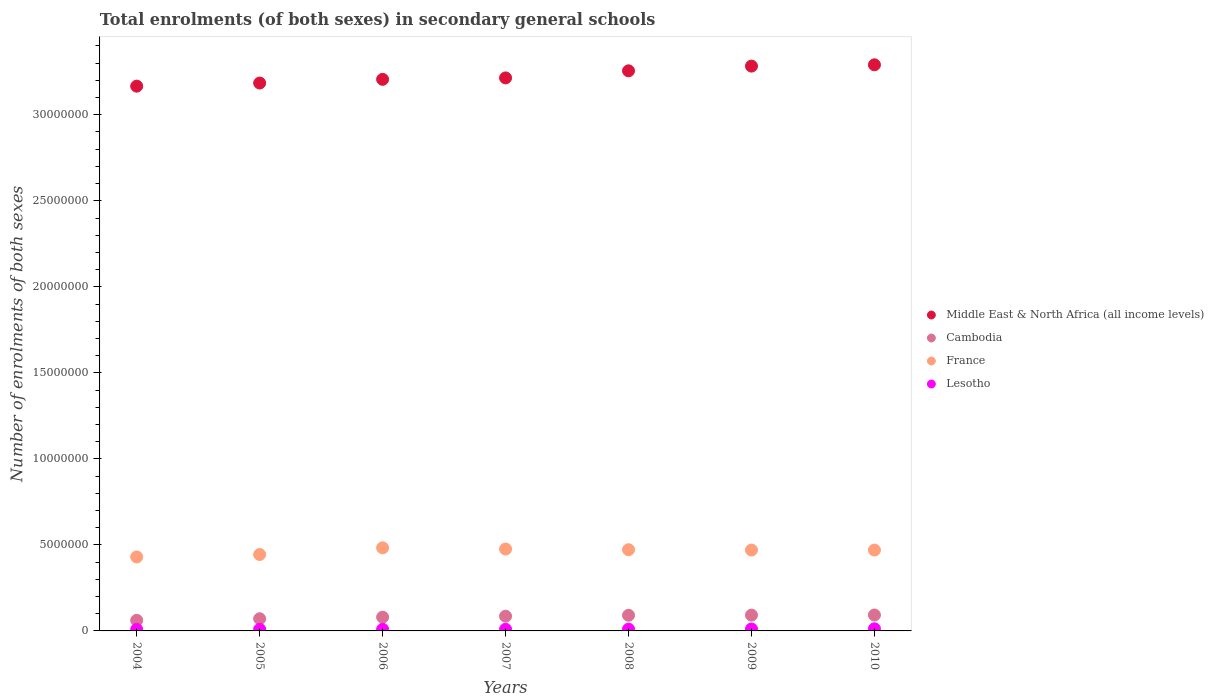How many different coloured dotlines are there?
Ensure brevity in your answer.  4. What is the number of enrolments in secondary schools in France in 2004?
Offer a very short reply. 4.30e+06. Across all years, what is the maximum number of enrolments in secondary schools in France?
Offer a terse response. 4.83e+06. Across all years, what is the minimum number of enrolments in secondary schools in Cambodia?
Your answer should be very brief. 6.16e+05. What is the total number of enrolments in secondary schools in Middle East & North Africa (all income levels) in the graph?
Keep it short and to the point. 2.26e+08. What is the difference between the number of enrolments in secondary schools in France in 2004 and that in 2010?
Give a very brief answer. -4.02e+05. What is the difference between the number of enrolments in secondary schools in Cambodia in 2006 and the number of enrolments in secondary schools in France in 2004?
Offer a terse response. -3.50e+06. What is the average number of enrolments in secondary schools in Cambodia per year?
Offer a very short reply. 8.19e+05. In the year 2004, what is the difference between the number of enrolments in secondary schools in France and number of enrolments in secondary schools in Middle East & North Africa (all income levels)?
Your answer should be very brief. -2.74e+07. What is the ratio of the number of enrolments in secondary schools in Lesotho in 2007 to that in 2008?
Ensure brevity in your answer.  0.95. Is the number of enrolments in secondary schools in Middle East & North Africa (all income levels) in 2005 less than that in 2010?
Your response must be concise. Yes. What is the difference between the highest and the second highest number of enrolments in secondary schools in Cambodia?
Make the answer very short. 7080. What is the difference between the highest and the lowest number of enrolments in secondary schools in Middle East & North Africa (all income levels)?
Your response must be concise. 1.24e+06. Is it the case that in every year, the sum of the number of enrolments in secondary schools in Cambodia and number of enrolments in secondary schools in France  is greater than the sum of number of enrolments in secondary schools in Lesotho and number of enrolments in secondary schools in Middle East & North Africa (all income levels)?
Your answer should be compact. No. Is it the case that in every year, the sum of the number of enrolments in secondary schools in Cambodia and number of enrolments in secondary schools in Middle East & North Africa (all income levels)  is greater than the number of enrolments in secondary schools in France?
Offer a very short reply. Yes. Does the number of enrolments in secondary schools in Cambodia monotonically increase over the years?
Offer a very short reply. Yes. Is the number of enrolments in secondary schools in Cambodia strictly greater than the number of enrolments in secondary schools in Middle East & North Africa (all income levels) over the years?
Provide a succinct answer. No. How many dotlines are there?
Your answer should be compact. 4. What is the difference between two consecutive major ticks on the Y-axis?
Offer a terse response. 5.00e+06. Does the graph contain any zero values?
Offer a terse response. No. How are the legend labels stacked?
Provide a short and direct response. Vertical. What is the title of the graph?
Offer a terse response. Total enrolments (of both sexes) in secondary general schools. What is the label or title of the X-axis?
Your answer should be compact. Years. What is the label or title of the Y-axis?
Your answer should be very brief. Number of enrolments of both sexes. What is the Number of enrolments of both sexes of Middle East & North Africa (all income levels) in 2004?
Offer a very short reply. 3.17e+07. What is the Number of enrolments of both sexes of Cambodia in 2004?
Your response must be concise. 6.16e+05. What is the Number of enrolments of both sexes of France in 2004?
Your answer should be very brief. 4.30e+06. What is the Number of enrolments of both sexes in Lesotho in 2004?
Ensure brevity in your answer.  8.81e+04. What is the Number of enrolments of both sexes of Middle East & North Africa (all income levels) in 2005?
Ensure brevity in your answer.  3.18e+07. What is the Number of enrolments of both sexes of Cambodia in 2005?
Provide a succinct answer. 7.08e+05. What is the Number of enrolments of both sexes of France in 2005?
Ensure brevity in your answer.  4.44e+06. What is the Number of enrolments of both sexes of Lesotho in 2005?
Offer a very short reply. 9.31e+04. What is the Number of enrolments of both sexes of Middle East & North Africa (all income levels) in 2006?
Ensure brevity in your answer.  3.21e+07. What is the Number of enrolments of both sexes in Cambodia in 2006?
Your answer should be very brief. 7.99e+05. What is the Number of enrolments of both sexes in France in 2006?
Offer a very short reply. 4.83e+06. What is the Number of enrolments of both sexes of Lesotho in 2006?
Provide a succinct answer. 9.45e+04. What is the Number of enrolments of both sexes in Middle East & North Africa (all income levels) in 2007?
Keep it short and to the point. 3.21e+07. What is the Number of enrolments of both sexes in Cambodia in 2007?
Provide a short and direct response. 8.56e+05. What is the Number of enrolments of both sexes of France in 2007?
Ensure brevity in your answer.  4.76e+06. What is the Number of enrolments of both sexes of Lesotho in 2007?
Your answer should be very brief. 9.79e+04. What is the Number of enrolments of both sexes in Middle East & North Africa (all income levels) in 2008?
Provide a succinct answer. 3.26e+07. What is the Number of enrolments of both sexes in Cambodia in 2008?
Offer a very short reply. 9.09e+05. What is the Number of enrolments of both sexes in France in 2008?
Provide a short and direct response. 4.72e+06. What is the Number of enrolments of both sexes in Lesotho in 2008?
Provide a succinct answer. 1.03e+05. What is the Number of enrolments of both sexes of Middle East & North Africa (all income levels) in 2009?
Ensure brevity in your answer.  3.28e+07. What is the Number of enrolments of both sexes in Cambodia in 2009?
Ensure brevity in your answer.  9.19e+05. What is the Number of enrolments of both sexes of France in 2009?
Your response must be concise. 4.70e+06. What is the Number of enrolments of both sexes of Lesotho in 2009?
Keep it short and to the point. 1.11e+05. What is the Number of enrolments of both sexes in Middle East & North Africa (all income levels) in 2010?
Keep it short and to the point. 3.29e+07. What is the Number of enrolments of both sexes of Cambodia in 2010?
Give a very brief answer. 9.26e+05. What is the Number of enrolments of both sexes of France in 2010?
Offer a very short reply. 4.70e+06. What is the Number of enrolments of both sexes of Lesotho in 2010?
Your answer should be very brief. 1.23e+05. Across all years, what is the maximum Number of enrolments of both sexes in Middle East & North Africa (all income levels)?
Offer a very short reply. 3.29e+07. Across all years, what is the maximum Number of enrolments of both sexes in Cambodia?
Provide a succinct answer. 9.26e+05. Across all years, what is the maximum Number of enrolments of both sexes in France?
Your response must be concise. 4.83e+06. Across all years, what is the maximum Number of enrolments of both sexes in Lesotho?
Keep it short and to the point. 1.23e+05. Across all years, what is the minimum Number of enrolments of both sexes of Middle East & North Africa (all income levels)?
Your answer should be very brief. 3.17e+07. Across all years, what is the minimum Number of enrolments of both sexes in Cambodia?
Offer a very short reply. 6.16e+05. Across all years, what is the minimum Number of enrolments of both sexes in France?
Offer a very short reply. 4.30e+06. Across all years, what is the minimum Number of enrolments of both sexes in Lesotho?
Make the answer very short. 8.81e+04. What is the total Number of enrolments of both sexes in Middle East & North Africa (all income levels) in the graph?
Offer a very short reply. 2.26e+08. What is the total Number of enrolments of both sexes in Cambodia in the graph?
Keep it short and to the point. 5.73e+06. What is the total Number of enrolments of both sexes in France in the graph?
Make the answer very short. 3.25e+07. What is the total Number of enrolments of both sexes in Lesotho in the graph?
Provide a short and direct response. 7.12e+05. What is the difference between the Number of enrolments of both sexes of Middle East & North Africa (all income levels) in 2004 and that in 2005?
Provide a short and direct response. -1.81e+05. What is the difference between the Number of enrolments of both sexes in Cambodia in 2004 and that in 2005?
Offer a terse response. -9.24e+04. What is the difference between the Number of enrolments of both sexes of France in 2004 and that in 2005?
Make the answer very short. -1.43e+05. What is the difference between the Number of enrolments of both sexes in Lesotho in 2004 and that in 2005?
Offer a very short reply. -4954. What is the difference between the Number of enrolments of both sexes in Middle East & North Africa (all income levels) in 2004 and that in 2006?
Offer a terse response. -3.96e+05. What is the difference between the Number of enrolments of both sexes of Cambodia in 2004 and that in 2006?
Provide a short and direct response. -1.83e+05. What is the difference between the Number of enrolments of both sexes in France in 2004 and that in 2006?
Your response must be concise. -5.31e+05. What is the difference between the Number of enrolments of both sexes in Lesotho in 2004 and that in 2006?
Ensure brevity in your answer.  -6403. What is the difference between the Number of enrolments of both sexes of Middle East & North Africa (all income levels) in 2004 and that in 2007?
Your response must be concise. -4.79e+05. What is the difference between the Number of enrolments of both sexes of Cambodia in 2004 and that in 2007?
Make the answer very short. -2.40e+05. What is the difference between the Number of enrolments of both sexes in France in 2004 and that in 2007?
Your answer should be compact. -4.62e+05. What is the difference between the Number of enrolments of both sexes in Lesotho in 2004 and that in 2007?
Ensure brevity in your answer.  -9794. What is the difference between the Number of enrolments of both sexes of Middle East & North Africa (all income levels) in 2004 and that in 2008?
Your answer should be compact. -8.91e+05. What is the difference between the Number of enrolments of both sexes in Cambodia in 2004 and that in 2008?
Ensure brevity in your answer.  -2.93e+05. What is the difference between the Number of enrolments of both sexes of France in 2004 and that in 2008?
Provide a succinct answer. -4.22e+05. What is the difference between the Number of enrolments of both sexes of Lesotho in 2004 and that in 2008?
Provide a short and direct response. -1.52e+04. What is the difference between the Number of enrolments of both sexes in Middle East & North Africa (all income levels) in 2004 and that in 2009?
Your answer should be very brief. -1.17e+06. What is the difference between the Number of enrolments of both sexes of Cambodia in 2004 and that in 2009?
Provide a short and direct response. -3.03e+05. What is the difference between the Number of enrolments of both sexes in France in 2004 and that in 2009?
Your answer should be very brief. -4.02e+05. What is the difference between the Number of enrolments of both sexes of Lesotho in 2004 and that in 2009?
Ensure brevity in your answer.  -2.33e+04. What is the difference between the Number of enrolments of both sexes of Middle East & North Africa (all income levels) in 2004 and that in 2010?
Give a very brief answer. -1.24e+06. What is the difference between the Number of enrolments of both sexes in Cambodia in 2004 and that in 2010?
Ensure brevity in your answer.  -3.10e+05. What is the difference between the Number of enrolments of both sexes in France in 2004 and that in 2010?
Offer a terse response. -4.02e+05. What is the difference between the Number of enrolments of both sexes of Lesotho in 2004 and that in 2010?
Provide a short and direct response. -3.52e+04. What is the difference between the Number of enrolments of both sexes in Middle East & North Africa (all income levels) in 2005 and that in 2006?
Ensure brevity in your answer.  -2.15e+05. What is the difference between the Number of enrolments of both sexes in Cambodia in 2005 and that in 2006?
Your answer should be compact. -9.04e+04. What is the difference between the Number of enrolments of both sexes in France in 2005 and that in 2006?
Your answer should be compact. -3.88e+05. What is the difference between the Number of enrolments of both sexes of Lesotho in 2005 and that in 2006?
Provide a short and direct response. -1449. What is the difference between the Number of enrolments of both sexes of Middle East & North Africa (all income levels) in 2005 and that in 2007?
Offer a terse response. -2.98e+05. What is the difference between the Number of enrolments of both sexes in Cambodia in 2005 and that in 2007?
Give a very brief answer. -1.48e+05. What is the difference between the Number of enrolments of both sexes in France in 2005 and that in 2007?
Give a very brief answer. -3.19e+05. What is the difference between the Number of enrolments of both sexes in Lesotho in 2005 and that in 2007?
Make the answer very short. -4840. What is the difference between the Number of enrolments of both sexes of Middle East & North Africa (all income levels) in 2005 and that in 2008?
Provide a succinct answer. -7.10e+05. What is the difference between the Number of enrolments of both sexes of Cambodia in 2005 and that in 2008?
Give a very brief answer. -2.01e+05. What is the difference between the Number of enrolments of both sexes of France in 2005 and that in 2008?
Your answer should be compact. -2.79e+05. What is the difference between the Number of enrolments of both sexes of Lesotho in 2005 and that in 2008?
Your answer should be very brief. -1.02e+04. What is the difference between the Number of enrolments of both sexes of Middle East & North Africa (all income levels) in 2005 and that in 2009?
Your answer should be very brief. -9.84e+05. What is the difference between the Number of enrolments of both sexes of Cambodia in 2005 and that in 2009?
Provide a short and direct response. -2.10e+05. What is the difference between the Number of enrolments of both sexes in France in 2005 and that in 2009?
Make the answer very short. -2.59e+05. What is the difference between the Number of enrolments of both sexes of Lesotho in 2005 and that in 2009?
Keep it short and to the point. -1.84e+04. What is the difference between the Number of enrolments of both sexes in Middle East & North Africa (all income levels) in 2005 and that in 2010?
Your answer should be compact. -1.06e+06. What is the difference between the Number of enrolments of both sexes of Cambodia in 2005 and that in 2010?
Your response must be concise. -2.17e+05. What is the difference between the Number of enrolments of both sexes in France in 2005 and that in 2010?
Give a very brief answer. -2.59e+05. What is the difference between the Number of enrolments of both sexes in Lesotho in 2005 and that in 2010?
Your answer should be very brief. -3.02e+04. What is the difference between the Number of enrolments of both sexes in Middle East & North Africa (all income levels) in 2006 and that in 2007?
Your answer should be very brief. -8.30e+04. What is the difference between the Number of enrolments of both sexes in Cambodia in 2006 and that in 2007?
Ensure brevity in your answer.  -5.73e+04. What is the difference between the Number of enrolments of both sexes in France in 2006 and that in 2007?
Provide a succinct answer. 6.85e+04. What is the difference between the Number of enrolments of both sexes of Lesotho in 2006 and that in 2007?
Offer a very short reply. -3391. What is the difference between the Number of enrolments of both sexes of Middle East & North Africa (all income levels) in 2006 and that in 2008?
Ensure brevity in your answer.  -4.95e+05. What is the difference between the Number of enrolments of both sexes in Cambodia in 2006 and that in 2008?
Offer a very short reply. -1.10e+05. What is the difference between the Number of enrolments of both sexes in France in 2006 and that in 2008?
Give a very brief answer. 1.09e+05. What is the difference between the Number of enrolments of both sexes in Lesotho in 2006 and that in 2008?
Provide a succinct answer. -8772. What is the difference between the Number of enrolments of both sexes in Middle East & North Africa (all income levels) in 2006 and that in 2009?
Give a very brief answer. -7.69e+05. What is the difference between the Number of enrolments of both sexes of Cambodia in 2006 and that in 2009?
Your answer should be compact. -1.20e+05. What is the difference between the Number of enrolments of both sexes of France in 2006 and that in 2009?
Give a very brief answer. 1.29e+05. What is the difference between the Number of enrolments of both sexes in Lesotho in 2006 and that in 2009?
Offer a very short reply. -1.69e+04. What is the difference between the Number of enrolments of both sexes in Middle East & North Africa (all income levels) in 2006 and that in 2010?
Provide a short and direct response. -8.45e+05. What is the difference between the Number of enrolments of both sexes of Cambodia in 2006 and that in 2010?
Give a very brief answer. -1.27e+05. What is the difference between the Number of enrolments of both sexes of France in 2006 and that in 2010?
Your answer should be very brief. 1.29e+05. What is the difference between the Number of enrolments of both sexes of Lesotho in 2006 and that in 2010?
Your answer should be very brief. -2.88e+04. What is the difference between the Number of enrolments of both sexes of Middle East & North Africa (all income levels) in 2007 and that in 2008?
Provide a short and direct response. -4.12e+05. What is the difference between the Number of enrolments of both sexes of Cambodia in 2007 and that in 2008?
Provide a succinct answer. -5.28e+04. What is the difference between the Number of enrolments of both sexes in France in 2007 and that in 2008?
Your answer should be compact. 4.01e+04. What is the difference between the Number of enrolments of both sexes in Lesotho in 2007 and that in 2008?
Make the answer very short. -5381. What is the difference between the Number of enrolments of both sexes in Middle East & North Africa (all income levels) in 2007 and that in 2009?
Offer a very short reply. -6.86e+05. What is the difference between the Number of enrolments of both sexes of Cambodia in 2007 and that in 2009?
Give a very brief answer. -6.25e+04. What is the difference between the Number of enrolments of both sexes of France in 2007 and that in 2009?
Your answer should be very brief. 6.07e+04. What is the difference between the Number of enrolments of both sexes in Lesotho in 2007 and that in 2009?
Your response must be concise. -1.35e+04. What is the difference between the Number of enrolments of both sexes of Middle East & North Africa (all income levels) in 2007 and that in 2010?
Your answer should be compact. -7.62e+05. What is the difference between the Number of enrolments of both sexes in Cambodia in 2007 and that in 2010?
Your response must be concise. -6.96e+04. What is the difference between the Number of enrolments of both sexes of France in 2007 and that in 2010?
Your answer should be compact. 6.08e+04. What is the difference between the Number of enrolments of both sexes in Lesotho in 2007 and that in 2010?
Ensure brevity in your answer.  -2.54e+04. What is the difference between the Number of enrolments of both sexes in Middle East & North Africa (all income levels) in 2008 and that in 2009?
Your answer should be very brief. -2.74e+05. What is the difference between the Number of enrolments of both sexes in Cambodia in 2008 and that in 2009?
Ensure brevity in your answer.  -9675. What is the difference between the Number of enrolments of both sexes of France in 2008 and that in 2009?
Offer a very short reply. 2.06e+04. What is the difference between the Number of enrolments of both sexes of Lesotho in 2008 and that in 2009?
Your answer should be very brief. -8163. What is the difference between the Number of enrolments of both sexes in Middle East & North Africa (all income levels) in 2008 and that in 2010?
Offer a terse response. -3.50e+05. What is the difference between the Number of enrolments of both sexes of Cambodia in 2008 and that in 2010?
Offer a terse response. -1.68e+04. What is the difference between the Number of enrolments of both sexes in France in 2008 and that in 2010?
Your answer should be very brief. 2.07e+04. What is the difference between the Number of enrolments of both sexes of Lesotho in 2008 and that in 2010?
Offer a terse response. -2.00e+04. What is the difference between the Number of enrolments of both sexes in Middle East & North Africa (all income levels) in 2009 and that in 2010?
Provide a succinct answer. -7.55e+04. What is the difference between the Number of enrolments of both sexes in Cambodia in 2009 and that in 2010?
Your answer should be very brief. -7080. What is the difference between the Number of enrolments of both sexes in France in 2009 and that in 2010?
Offer a very short reply. 153. What is the difference between the Number of enrolments of both sexes in Lesotho in 2009 and that in 2010?
Your answer should be compact. -1.18e+04. What is the difference between the Number of enrolments of both sexes in Middle East & North Africa (all income levels) in 2004 and the Number of enrolments of both sexes in Cambodia in 2005?
Offer a terse response. 3.10e+07. What is the difference between the Number of enrolments of both sexes of Middle East & North Africa (all income levels) in 2004 and the Number of enrolments of both sexes of France in 2005?
Offer a terse response. 2.72e+07. What is the difference between the Number of enrolments of both sexes in Middle East & North Africa (all income levels) in 2004 and the Number of enrolments of both sexes in Lesotho in 2005?
Keep it short and to the point. 3.16e+07. What is the difference between the Number of enrolments of both sexes of Cambodia in 2004 and the Number of enrolments of both sexes of France in 2005?
Keep it short and to the point. -3.83e+06. What is the difference between the Number of enrolments of both sexes of Cambodia in 2004 and the Number of enrolments of both sexes of Lesotho in 2005?
Keep it short and to the point. 5.23e+05. What is the difference between the Number of enrolments of both sexes of France in 2004 and the Number of enrolments of both sexes of Lesotho in 2005?
Offer a terse response. 4.21e+06. What is the difference between the Number of enrolments of both sexes of Middle East & North Africa (all income levels) in 2004 and the Number of enrolments of both sexes of Cambodia in 2006?
Your answer should be compact. 3.09e+07. What is the difference between the Number of enrolments of both sexes in Middle East & North Africa (all income levels) in 2004 and the Number of enrolments of both sexes in France in 2006?
Your answer should be compact. 2.68e+07. What is the difference between the Number of enrolments of both sexes of Middle East & North Africa (all income levels) in 2004 and the Number of enrolments of both sexes of Lesotho in 2006?
Provide a short and direct response. 3.16e+07. What is the difference between the Number of enrolments of both sexes of Cambodia in 2004 and the Number of enrolments of both sexes of France in 2006?
Provide a short and direct response. -4.21e+06. What is the difference between the Number of enrolments of both sexes in Cambodia in 2004 and the Number of enrolments of both sexes in Lesotho in 2006?
Offer a terse response. 5.22e+05. What is the difference between the Number of enrolments of both sexes of France in 2004 and the Number of enrolments of both sexes of Lesotho in 2006?
Offer a terse response. 4.20e+06. What is the difference between the Number of enrolments of both sexes of Middle East & North Africa (all income levels) in 2004 and the Number of enrolments of both sexes of Cambodia in 2007?
Offer a terse response. 3.08e+07. What is the difference between the Number of enrolments of both sexes of Middle East & North Africa (all income levels) in 2004 and the Number of enrolments of both sexes of France in 2007?
Give a very brief answer. 2.69e+07. What is the difference between the Number of enrolments of both sexes in Middle East & North Africa (all income levels) in 2004 and the Number of enrolments of both sexes in Lesotho in 2007?
Your answer should be very brief. 3.16e+07. What is the difference between the Number of enrolments of both sexes in Cambodia in 2004 and the Number of enrolments of both sexes in France in 2007?
Offer a terse response. -4.14e+06. What is the difference between the Number of enrolments of both sexes in Cambodia in 2004 and the Number of enrolments of both sexes in Lesotho in 2007?
Your answer should be very brief. 5.18e+05. What is the difference between the Number of enrolments of both sexes of France in 2004 and the Number of enrolments of both sexes of Lesotho in 2007?
Your answer should be compact. 4.20e+06. What is the difference between the Number of enrolments of both sexes in Middle East & North Africa (all income levels) in 2004 and the Number of enrolments of both sexes in Cambodia in 2008?
Your answer should be compact. 3.08e+07. What is the difference between the Number of enrolments of both sexes in Middle East & North Africa (all income levels) in 2004 and the Number of enrolments of both sexes in France in 2008?
Offer a terse response. 2.69e+07. What is the difference between the Number of enrolments of both sexes in Middle East & North Africa (all income levels) in 2004 and the Number of enrolments of both sexes in Lesotho in 2008?
Ensure brevity in your answer.  3.16e+07. What is the difference between the Number of enrolments of both sexes of Cambodia in 2004 and the Number of enrolments of both sexes of France in 2008?
Keep it short and to the point. -4.10e+06. What is the difference between the Number of enrolments of both sexes of Cambodia in 2004 and the Number of enrolments of both sexes of Lesotho in 2008?
Keep it short and to the point. 5.13e+05. What is the difference between the Number of enrolments of both sexes in France in 2004 and the Number of enrolments of both sexes in Lesotho in 2008?
Give a very brief answer. 4.20e+06. What is the difference between the Number of enrolments of both sexes of Middle East & North Africa (all income levels) in 2004 and the Number of enrolments of both sexes of Cambodia in 2009?
Provide a succinct answer. 3.07e+07. What is the difference between the Number of enrolments of both sexes of Middle East & North Africa (all income levels) in 2004 and the Number of enrolments of both sexes of France in 2009?
Your answer should be compact. 2.70e+07. What is the difference between the Number of enrolments of both sexes in Middle East & North Africa (all income levels) in 2004 and the Number of enrolments of both sexes in Lesotho in 2009?
Make the answer very short. 3.16e+07. What is the difference between the Number of enrolments of both sexes of Cambodia in 2004 and the Number of enrolments of both sexes of France in 2009?
Provide a short and direct response. -4.08e+06. What is the difference between the Number of enrolments of both sexes in Cambodia in 2004 and the Number of enrolments of both sexes in Lesotho in 2009?
Keep it short and to the point. 5.05e+05. What is the difference between the Number of enrolments of both sexes of France in 2004 and the Number of enrolments of both sexes of Lesotho in 2009?
Provide a short and direct response. 4.19e+06. What is the difference between the Number of enrolments of both sexes in Middle East & North Africa (all income levels) in 2004 and the Number of enrolments of both sexes in Cambodia in 2010?
Offer a terse response. 3.07e+07. What is the difference between the Number of enrolments of both sexes of Middle East & North Africa (all income levels) in 2004 and the Number of enrolments of both sexes of France in 2010?
Offer a very short reply. 2.70e+07. What is the difference between the Number of enrolments of both sexes in Middle East & North Africa (all income levels) in 2004 and the Number of enrolments of both sexes in Lesotho in 2010?
Keep it short and to the point. 3.15e+07. What is the difference between the Number of enrolments of both sexes of Cambodia in 2004 and the Number of enrolments of both sexes of France in 2010?
Keep it short and to the point. -4.08e+06. What is the difference between the Number of enrolments of both sexes in Cambodia in 2004 and the Number of enrolments of both sexes in Lesotho in 2010?
Offer a very short reply. 4.93e+05. What is the difference between the Number of enrolments of both sexes of France in 2004 and the Number of enrolments of both sexes of Lesotho in 2010?
Provide a short and direct response. 4.18e+06. What is the difference between the Number of enrolments of both sexes of Middle East & North Africa (all income levels) in 2005 and the Number of enrolments of both sexes of Cambodia in 2006?
Provide a short and direct response. 3.10e+07. What is the difference between the Number of enrolments of both sexes in Middle East & North Africa (all income levels) in 2005 and the Number of enrolments of both sexes in France in 2006?
Keep it short and to the point. 2.70e+07. What is the difference between the Number of enrolments of both sexes in Middle East & North Africa (all income levels) in 2005 and the Number of enrolments of both sexes in Lesotho in 2006?
Make the answer very short. 3.18e+07. What is the difference between the Number of enrolments of both sexes in Cambodia in 2005 and the Number of enrolments of both sexes in France in 2006?
Ensure brevity in your answer.  -4.12e+06. What is the difference between the Number of enrolments of both sexes of Cambodia in 2005 and the Number of enrolments of both sexes of Lesotho in 2006?
Your response must be concise. 6.14e+05. What is the difference between the Number of enrolments of both sexes of France in 2005 and the Number of enrolments of both sexes of Lesotho in 2006?
Offer a very short reply. 4.35e+06. What is the difference between the Number of enrolments of both sexes in Middle East & North Africa (all income levels) in 2005 and the Number of enrolments of both sexes in Cambodia in 2007?
Keep it short and to the point. 3.10e+07. What is the difference between the Number of enrolments of both sexes in Middle East & North Africa (all income levels) in 2005 and the Number of enrolments of both sexes in France in 2007?
Offer a very short reply. 2.71e+07. What is the difference between the Number of enrolments of both sexes of Middle East & North Africa (all income levels) in 2005 and the Number of enrolments of both sexes of Lesotho in 2007?
Your answer should be compact. 3.17e+07. What is the difference between the Number of enrolments of both sexes of Cambodia in 2005 and the Number of enrolments of both sexes of France in 2007?
Ensure brevity in your answer.  -4.05e+06. What is the difference between the Number of enrolments of both sexes of Cambodia in 2005 and the Number of enrolments of both sexes of Lesotho in 2007?
Offer a terse response. 6.11e+05. What is the difference between the Number of enrolments of both sexes in France in 2005 and the Number of enrolments of both sexes in Lesotho in 2007?
Provide a succinct answer. 4.34e+06. What is the difference between the Number of enrolments of both sexes in Middle East & North Africa (all income levels) in 2005 and the Number of enrolments of both sexes in Cambodia in 2008?
Make the answer very short. 3.09e+07. What is the difference between the Number of enrolments of both sexes in Middle East & North Africa (all income levels) in 2005 and the Number of enrolments of both sexes in France in 2008?
Your answer should be very brief. 2.71e+07. What is the difference between the Number of enrolments of both sexes of Middle East & North Africa (all income levels) in 2005 and the Number of enrolments of both sexes of Lesotho in 2008?
Your response must be concise. 3.17e+07. What is the difference between the Number of enrolments of both sexes of Cambodia in 2005 and the Number of enrolments of both sexes of France in 2008?
Offer a terse response. -4.01e+06. What is the difference between the Number of enrolments of both sexes in Cambodia in 2005 and the Number of enrolments of both sexes in Lesotho in 2008?
Offer a terse response. 6.05e+05. What is the difference between the Number of enrolments of both sexes of France in 2005 and the Number of enrolments of both sexes of Lesotho in 2008?
Provide a succinct answer. 4.34e+06. What is the difference between the Number of enrolments of both sexes in Middle East & North Africa (all income levels) in 2005 and the Number of enrolments of both sexes in Cambodia in 2009?
Make the answer very short. 3.09e+07. What is the difference between the Number of enrolments of both sexes of Middle East & North Africa (all income levels) in 2005 and the Number of enrolments of both sexes of France in 2009?
Your answer should be compact. 2.71e+07. What is the difference between the Number of enrolments of both sexes of Middle East & North Africa (all income levels) in 2005 and the Number of enrolments of both sexes of Lesotho in 2009?
Ensure brevity in your answer.  3.17e+07. What is the difference between the Number of enrolments of both sexes in Cambodia in 2005 and the Number of enrolments of both sexes in France in 2009?
Make the answer very short. -3.99e+06. What is the difference between the Number of enrolments of both sexes of Cambodia in 2005 and the Number of enrolments of both sexes of Lesotho in 2009?
Offer a very short reply. 5.97e+05. What is the difference between the Number of enrolments of both sexes in France in 2005 and the Number of enrolments of both sexes in Lesotho in 2009?
Provide a short and direct response. 4.33e+06. What is the difference between the Number of enrolments of both sexes in Middle East & North Africa (all income levels) in 2005 and the Number of enrolments of both sexes in Cambodia in 2010?
Your answer should be very brief. 3.09e+07. What is the difference between the Number of enrolments of both sexes in Middle East & North Africa (all income levels) in 2005 and the Number of enrolments of both sexes in France in 2010?
Give a very brief answer. 2.71e+07. What is the difference between the Number of enrolments of both sexes of Middle East & North Africa (all income levels) in 2005 and the Number of enrolments of both sexes of Lesotho in 2010?
Your response must be concise. 3.17e+07. What is the difference between the Number of enrolments of both sexes in Cambodia in 2005 and the Number of enrolments of both sexes in France in 2010?
Provide a short and direct response. -3.99e+06. What is the difference between the Number of enrolments of both sexes of Cambodia in 2005 and the Number of enrolments of both sexes of Lesotho in 2010?
Make the answer very short. 5.85e+05. What is the difference between the Number of enrolments of both sexes of France in 2005 and the Number of enrolments of both sexes of Lesotho in 2010?
Your answer should be very brief. 4.32e+06. What is the difference between the Number of enrolments of both sexes in Middle East & North Africa (all income levels) in 2006 and the Number of enrolments of both sexes in Cambodia in 2007?
Your response must be concise. 3.12e+07. What is the difference between the Number of enrolments of both sexes in Middle East & North Africa (all income levels) in 2006 and the Number of enrolments of both sexes in France in 2007?
Give a very brief answer. 2.73e+07. What is the difference between the Number of enrolments of both sexes of Middle East & North Africa (all income levels) in 2006 and the Number of enrolments of both sexes of Lesotho in 2007?
Keep it short and to the point. 3.20e+07. What is the difference between the Number of enrolments of both sexes of Cambodia in 2006 and the Number of enrolments of both sexes of France in 2007?
Offer a terse response. -3.96e+06. What is the difference between the Number of enrolments of both sexes in Cambodia in 2006 and the Number of enrolments of both sexes in Lesotho in 2007?
Offer a terse response. 7.01e+05. What is the difference between the Number of enrolments of both sexes of France in 2006 and the Number of enrolments of both sexes of Lesotho in 2007?
Your answer should be very brief. 4.73e+06. What is the difference between the Number of enrolments of both sexes of Middle East & North Africa (all income levels) in 2006 and the Number of enrolments of both sexes of Cambodia in 2008?
Make the answer very short. 3.12e+07. What is the difference between the Number of enrolments of both sexes in Middle East & North Africa (all income levels) in 2006 and the Number of enrolments of both sexes in France in 2008?
Provide a short and direct response. 2.73e+07. What is the difference between the Number of enrolments of both sexes in Middle East & North Africa (all income levels) in 2006 and the Number of enrolments of both sexes in Lesotho in 2008?
Offer a terse response. 3.20e+07. What is the difference between the Number of enrolments of both sexes of Cambodia in 2006 and the Number of enrolments of both sexes of France in 2008?
Provide a short and direct response. -3.92e+06. What is the difference between the Number of enrolments of both sexes in Cambodia in 2006 and the Number of enrolments of both sexes in Lesotho in 2008?
Ensure brevity in your answer.  6.96e+05. What is the difference between the Number of enrolments of both sexes of France in 2006 and the Number of enrolments of both sexes of Lesotho in 2008?
Your answer should be compact. 4.73e+06. What is the difference between the Number of enrolments of both sexes of Middle East & North Africa (all income levels) in 2006 and the Number of enrolments of both sexes of Cambodia in 2009?
Offer a terse response. 3.11e+07. What is the difference between the Number of enrolments of both sexes in Middle East & North Africa (all income levels) in 2006 and the Number of enrolments of both sexes in France in 2009?
Offer a terse response. 2.74e+07. What is the difference between the Number of enrolments of both sexes in Middle East & North Africa (all income levels) in 2006 and the Number of enrolments of both sexes in Lesotho in 2009?
Offer a very short reply. 3.19e+07. What is the difference between the Number of enrolments of both sexes in Cambodia in 2006 and the Number of enrolments of both sexes in France in 2009?
Make the answer very short. -3.90e+06. What is the difference between the Number of enrolments of both sexes in Cambodia in 2006 and the Number of enrolments of both sexes in Lesotho in 2009?
Your response must be concise. 6.87e+05. What is the difference between the Number of enrolments of both sexes of France in 2006 and the Number of enrolments of both sexes of Lesotho in 2009?
Your answer should be compact. 4.72e+06. What is the difference between the Number of enrolments of both sexes of Middle East & North Africa (all income levels) in 2006 and the Number of enrolments of both sexes of Cambodia in 2010?
Ensure brevity in your answer.  3.11e+07. What is the difference between the Number of enrolments of both sexes in Middle East & North Africa (all income levels) in 2006 and the Number of enrolments of both sexes in France in 2010?
Make the answer very short. 2.74e+07. What is the difference between the Number of enrolments of both sexes of Middle East & North Africa (all income levels) in 2006 and the Number of enrolments of both sexes of Lesotho in 2010?
Your answer should be compact. 3.19e+07. What is the difference between the Number of enrolments of both sexes of Cambodia in 2006 and the Number of enrolments of both sexes of France in 2010?
Provide a short and direct response. -3.90e+06. What is the difference between the Number of enrolments of both sexes in Cambodia in 2006 and the Number of enrolments of both sexes in Lesotho in 2010?
Offer a very short reply. 6.76e+05. What is the difference between the Number of enrolments of both sexes of France in 2006 and the Number of enrolments of both sexes of Lesotho in 2010?
Your response must be concise. 4.71e+06. What is the difference between the Number of enrolments of both sexes of Middle East & North Africa (all income levels) in 2007 and the Number of enrolments of both sexes of Cambodia in 2008?
Make the answer very short. 3.12e+07. What is the difference between the Number of enrolments of both sexes in Middle East & North Africa (all income levels) in 2007 and the Number of enrolments of both sexes in France in 2008?
Offer a terse response. 2.74e+07. What is the difference between the Number of enrolments of both sexes of Middle East & North Africa (all income levels) in 2007 and the Number of enrolments of both sexes of Lesotho in 2008?
Provide a succinct answer. 3.20e+07. What is the difference between the Number of enrolments of both sexes in Cambodia in 2007 and the Number of enrolments of both sexes in France in 2008?
Your answer should be very brief. -3.86e+06. What is the difference between the Number of enrolments of both sexes of Cambodia in 2007 and the Number of enrolments of both sexes of Lesotho in 2008?
Keep it short and to the point. 7.53e+05. What is the difference between the Number of enrolments of both sexes in France in 2007 and the Number of enrolments of both sexes in Lesotho in 2008?
Your answer should be very brief. 4.66e+06. What is the difference between the Number of enrolments of both sexes of Middle East & North Africa (all income levels) in 2007 and the Number of enrolments of both sexes of Cambodia in 2009?
Provide a succinct answer. 3.12e+07. What is the difference between the Number of enrolments of both sexes in Middle East & North Africa (all income levels) in 2007 and the Number of enrolments of both sexes in France in 2009?
Offer a very short reply. 2.74e+07. What is the difference between the Number of enrolments of both sexes in Middle East & North Africa (all income levels) in 2007 and the Number of enrolments of both sexes in Lesotho in 2009?
Ensure brevity in your answer.  3.20e+07. What is the difference between the Number of enrolments of both sexes in Cambodia in 2007 and the Number of enrolments of both sexes in France in 2009?
Provide a short and direct response. -3.84e+06. What is the difference between the Number of enrolments of both sexes of Cambodia in 2007 and the Number of enrolments of both sexes of Lesotho in 2009?
Your answer should be very brief. 7.45e+05. What is the difference between the Number of enrolments of both sexes in France in 2007 and the Number of enrolments of both sexes in Lesotho in 2009?
Offer a terse response. 4.65e+06. What is the difference between the Number of enrolments of both sexes in Middle East & North Africa (all income levels) in 2007 and the Number of enrolments of both sexes in Cambodia in 2010?
Ensure brevity in your answer.  3.12e+07. What is the difference between the Number of enrolments of both sexes in Middle East & North Africa (all income levels) in 2007 and the Number of enrolments of both sexes in France in 2010?
Give a very brief answer. 2.74e+07. What is the difference between the Number of enrolments of both sexes in Middle East & North Africa (all income levels) in 2007 and the Number of enrolments of both sexes in Lesotho in 2010?
Your answer should be very brief. 3.20e+07. What is the difference between the Number of enrolments of both sexes in Cambodia in 2007 and the Number of enrolments of both sexes in France in 2010?
Your response must be concise. -3.84e+06. What is the difference between the Number of enrolments of both sexes of Cambodia in 2007 and the Number of enrolments of both sexes of Lesotho in 2010?
Offer a very short reply. 7.33e+05. What is the difference between the Number of enrolments of both sexes of France in 2007 and the Number of enrolments of both sexes of Lesotho in 2010?
Ensure brevity in your answer.  4.64e+06. What is the difference between the Number of enrolments of both sexes of Middle East & North Africa (all income levels) in 2008 and the Number of enrolments of both sexes of Cambodia in 2009?
Offer a terse response. 3.16e+07. What is the difference between the Number of enrolments of both sexes in Middle East & North Africa (all income levels) in 2008 and the Number of enrolments of both sexes in France in 2009?
Your answer should be compact. 2.79e+07. What is the difference between the Number of enrolments of both sexes in Middle East & North Africa (all income levels) in 2008 and the Number of enrolments of both sexes in Lesotho in 2009?
Give a very brief answer. 3.24e+07. What is the difference between the Number of enrolments of both sexes in Cambodia in 2008 and the Number of enrolments of both sexes in France in 2009?
Provide a succinct answer. -3.79e+06. What is the difference between the Number of enrolments of both sexes of Cambodia in 2008 and the Number of enrolments of both sexes of Lesotho in 2009?
Offer a terse response. 7.98e+05. What is the difference between the Number of enrolments of both sexes of France in 2008 and the Number of enrolments of both sexes of Lesotho in 2009?
Offer a very short reply. 4.61e+06. What is the difference between the Number of enrolments of both sexes of Middle East & North Africa (all income levels) in 2008 and the Number of enrolments of both sexes of Cambodia in 2010?
Offer a terse response. 3.16e+07. What is the difference between the Number of enrolments of both sexes of Middle East & North Africa (all income levels) in 2008 and the Number of enrolments of both sexes of France in 2010?
Offer a terse response. 2.79e+07. What is the difference between the Number of enrolments of both sexes in Middle East & North Africa (all income levels) in 2008 and the Number of enrolments of both sexes in Lesotho in 2010?
Make the answer very short. 3.24e+07. What is the difference between the Number of enrolments of both sexes of Cambodia in 2008 and the Number of enrolments of both sexes of France in 2010?
Make the answer very short. -3.79e+06. What is the difference between the Number of enrolments of both sexes in Cambodia in 2008 and the Number of enrolments of both sexes in Lesotho in 2010?
Provide a short and direct response. 7.86e+05. What is the difference between the Number of enrolments of both sexes of France in 2008 and the Number of enrolments of both sexes of Lesotho in 2010?
Give a very brief answer. 4.60e+06. What is the difference between the Number of enrolments of both sexes of Middle East & North Africa (all income levels) in 2009 and the Number of enrolments of both sexes of Cambodia in 2010?
Provide a succinct answer. 3.19e+07. What is the difference between the Number of enrolments of both sexes in Middle East & North Africa (all income levels) in 2009 and the Number of enrolments of both sexes in France in 2010?
Offer a terse response. 2.81e+07. What is the difference between the Number of enrolments of both sexes in Middle East & North Africa (all income levels) in 2009 and the Number of enrolments of both sexes in Lesotho in 2010?
Make the answer very short. 3.27e+07. What is the difference between the Number of enrolments of both sexes in Cambodia in 2009 and the Number of enrolments of both sexes in France in 2010?
Offer a very short reply. -3.78e+06. What is the difference between the Number of enrolments of both sexes in Cambodia in 2009 and the Number of enrolments of both sexes in Lesotho in 2010?
Offer a terse response. 7.95e+05. What is the difference between the Number of enrolments of both sexes in France in 2009 and the Number of enrolments of both sexes in Lesotho in 2010?
Your answer should be very brief. 4.58e+06. What is the average Number of enrolments of both sexes in Middle East & North Africa (all income levels) per year?
Provide a succinct answer. 3.23e+07. What is the average Number of enrolments of both sexes in Cambodia per year?
Your answer should be compact. 8.19e+05. What is the average Number of enrolments of both sexes in France per year?
Your answer should be very brief. 4.64e+06. What is the average Number of enrolments of both sexes of Lesotho per year?
Make the answer very short. 1.02e+05. In the year 2004, what is the difference between the Number of enrolments of both sexes in Middle East & North Africa (all income levels) and Number of enrolments of both sexes in Cambodia?
Offer a terse response. 3.10e+07. In the year 2004, what is the difference between the Number of enrolments of both sexes in Middle East & North Africa (all income levels) and Number of enrolments of both sexes in France?
Provide a succinct answer. 2.74e+07. In the year 2004, what is the difference between the Number of enrolments of both sexes of Middle East & North Africa (all income levels) and Number of enrolments of both sexes of Lesotho?
Offer a terse response. 3.16e+07. In the year 2004, what is the difference between the Number of enrolments of both sexes in Cambodia and Number of enrolments of both sexes in France?
Offer a terse response. -3.68e+06. In the year 2004, what is the difference between the Number of enrolments of both sexes of Cambodia and Number of enrolments of both sexes of Lesotho?
Give a very brief answer. 5.28e+05. In the year 2004, what is the difference between the Number of enrolments of both sexes of France and Number of enrolments of both sexes of Lesotho?
Give a very brief answer. 4.21e+06. In the year 2005, what is the difference between the Number of enrolments of both sexes in Middle East & North Africa (all income levels) and Number of enrolments of both sexes in Cambodia?
Offer a terse response. 3.11e+07. In the year 2005, what is the difference between the Number of enrolments of both sexes of Middle East & North Africa (all income levels) and Number of enrolments of both sexes of France?
Keep it short and to the point. 2.74e+07. In the year 2005, what is the difference between the Number of enrolments of both sexes of Middle East & North Africa (all income levels) and Number of enrolments of both sexes of Lesotho?
Keep it short and to the point. 3.18e+07. In the year 2005, what is the difference between the Number of enrolments of both sexes in Cambodia and Number of enrolments of both sexes in France?
Your response must be concise. -3.73e+06. In the year 2005, what is the difference between the Number of enrolments of both sexes of Cambodia and Number of enrolments of both sexes of Lesotho?
Make the answer very short. 6.15e+05. In the year 2005, what is the difference between the Number of enrolments of both sexes in France and Number of enrolments of both sexes in Lesotho?
Provide a short and direct response. 4.35e+06. In the year 2006, what is the difference between the Number of enrolments of both sexes of Middle East & North Africa (all income levels) and Number of enrolments of both sexes of Cambodia?
Your response must be concise. 3.13e+07. In the year 2006, what is the difference between the Number of enrolments of both sexes in Middle East & North Africa (all income levels) and Number of enrolments of both sexes in France?
Ensure brevity in your answer.  2.72e+07. In the year 2006, what is the difference between the Number of enrolments of both sexes in Middle East & North Africa (all income levels) and Number of enrolments of both sexes in Lesotho?
Ensure brevity in your answer.  3.20e+07. In the year 2006, what is the difference between the Number of enrolments of both sexes of Cambodia and Number of enrolments of both sexes of France?
Ensure brevity in your answer.  -4.03e+06. In the year 2006, what is the difference between the Number of enrolments of both sexes in Cambodia and Number of enrolments of both sexes in Lesotho?
Keep it short and to the point. 7.04e+05. In the year 2006, what is the difference between the Number of enrolments of both sexes of France and Number of enrolments of both sexes of Lesotho?
Provide a succinct answer. 4.73e+06. In the year 2007, what is the difference between the Number of enrolments of both sexes in Middle East & North Africa (all income levels) and Number of enrolments of both sexes in Cambodia?
Provide a succinct answer. 3.13e+07. In the year 2007, what is the difference between the Number of enrolments of both sexes of Middle East & North Africa (all income levels) and Number of enrolments of both sexes of France?
Provide a short and direct response. 2.74e+07. In the year 2007, what is the difference between the Number of enrolments of both sexes of Middle East & North Africa (all income levels) and Number of enrolments of both sexes of Lesotho?
Provide a short and direct response. 3.20e+07. In the year 2007, what is the difference between the Number of enrolments of both sexes in Cambodia and Number of enrolments of both sexes in France?
Your answer should be compact. -3.90e+06. In the year 2007, what is the difference between the Number of enrolments of both sexes in Cambodia and Number of enrolments of both sexes in Lesotho?
Your answer should be very brief. 7.58e+05. In the year 2007, what is the difference between the Number of enrolments of both sexes of France and Number of enrolments of both sexes of Lesotho?
Ensure brevity in your answer.  4.66e+06. In the year 2008, what is the difference between the Number of enrolments of both sexes of Middle East & North Africa (all income levels) and Number of enrolments of both sexes of Cambodia?
Provide a succinct answer. 3.16e+07. In the year 2008, what is the difference between the Number of enrolments of both sexes of Middle East & North Africa (all income levels) and Number of enrolments of both sexes of France?
Offer a very short reply. 2.78e+07. In the year 2008, what is the difference between the Number of enrolments of both sexes in Middle East & North Africa (all income levels) and Number of enrolments of both sexes in Lesotho?
Your answer should be compact. 3.25e+07. In the year 2008, what is the difference between the Number of enrolments of both sexes in Cambodia and Number of enrolments of both sexes in France?
Offer a very short reply. -3.81e+06. In the year 2008, what is the difference between the Number of enrolments of both sexes in Cambodia and Number of enrolments of both sexes in Lesotho?
Your answer should be compact. 8.06e+05. In the year 2008, what is the difference between the Number of enrolments of both sexes in France and Number of enrolments of both sexes in Lesotho?
Give a very brief answer. 4.62e+06. In the year 2009, what is the difference between the Number of enrolments of both sexes in Middle East & North Africa (all income levels) and Number of enrolments of both sexes in Cambodia?
Provide a succinct answer. 3.19e+07. In the year 2009, what is the difference between the Number of enrolments of both sexes of Middle East & North Africa (all income levels) and Number of enrolments of both sexes of France?
Offer a very short reply. 2.81e+07. In the year 2009, what is the difference between the Number of enrolments of both sexes of Middle East & North Africa (all income levels) and Number of enrolments of both sexes of Lesotho?
Your answer should be compact. 3.27e+07. In the year 2009, what is the difference between the Number of enrolments of both sexes of Cambodia and Number of enrolments of both sexes of France?
Your answer should be compact. -3.78e+06. In the year 2009, what is the difference between the Number of enrolments of both sexes of Cambodia and Number of enrolments of both sexes of Lesotho?
Give a very brief answer. 8.07e+05. In the year 2009, what is the difference between the Number of enrolments of both sexes in France and Number of enrolments of both sexes in Lesotho?
Ensure brevity in your answer.  4.59e+06. In the year 2010, what is the difference between the Number of enrolments of both sexes of Middle East & North Africa (all income levels) and Number of enrolments of both sexes of Cambodia?
Give a very brief answer. 3.20e+07. In the year 2010, what is the difference between the Number of enrolments of both sexes in Middle East & North Africa (all income levels) and Number of enrolments of both sexes in France?
Offer a terse response. 2.82e+07. In the year 2010, what is the difference between the Number of enrolments of both sexes in Middle East & North Africa (all income levels) and Number of enrolments of both sexes in Lesotho?
Make the answer very short. 3.28e+07. In the year 2010, what is the difference between the Number of enrolments of both sexes of Cambodia and Number of enrolments of both sexes of France?
Provide a short and direct response. -3.77e+06. In the year 2010, what is the difference between the Number of enrolments of both sexes in Cambodia and Number of enrolments of both sexes in Lesotho?
Ensure brevity in your answer.  8.02e+05. In the year 2010, what is the difference between the Number of enrolments of both sexes of France and Number of enrolments of both sexes of Lesotho?
Make the answer very short. 4.58e+06. What is the ratio of the Number of enrolments of both sexes of Middle East & North Africa (all income levels) in 2004 to that in 2005?
Make the answer very short. 0.99. What is the ratio of the Number of enrolments of both sexes in Cambodia in 2004 to that in 2005?
Your answer should be very brief. 0.87. What is the ratio of the Number of enrolments of both sexes of France in 2004 to that in 2005?
Ensure brevity in your answer.  0.97. What is the ratio of the Number of enrolments of both sexes of Lesotho in 2004 to that in 2005?
Make the answer very short. 0.95. What is the ratio of the Number of enrolments of both sexes of Middle East & North Africa (all income levels) in 2004 to that in 2006?
Provide a short and direct response. 0.99. What is the ratio of the Number of enrolments of both sexes of Cambodia in 2004 to that in 2006?
Provide a succinct answer. 0.77. What is the ratio of the Number of enrolments of both sexes in France in 2004 to that in 2006?
Offer a very short reply. 0.89. What is the ratio of the Number of enrolments of both sexes of Lesotho in 2004 to that in 2006?
Ensure brevity in your answer.  0.93. What is the ratio of the Number of enrolments of both sexes in Middle East & North Africa (all income levels) in 2004 to that in 2007?
Ensure brevity in your answer.  0.99. What is the ratio of the Number of enrolments of both sexes of Cambodia in 2004 to that in 2007?
Offer a terse response. 0.72. What is the ratio of the Number of enrolments of both sexes in France in 2004 to that in 2007?
Offer a very short reply. 0.9. What is the ratio of the Number of enrolments of both sexes of Lesotho in 2004 to that in 2007?
Make the answer very short. 0.9. What is the ratio of the Number of enrolments of both sexes in Middle East & North Africa (all income levels) in 2004 to that in 2008?
Keep it short and to the point. 0.97. What is the ratio of the Number of enrolments of both sexes of Cambodia in 2004 to that in 2008?
Your response must be concise. 0.68. What is the ratio of the Number of enrolments of both sexes of France in 2004 to that in 2008?
Your answer should be very brief. 0.91. What is the ratio of the Number of enrolments of both sexes of Lesotho in 2004 to that in 2008?
Provide a short and direct response. 0.85. What is the ratio of the Number of enrolments of both sexes of Middle East & North Africa (all income levels) in 2004 to that in 2009?
Ensure brevity in your answer.  0.96. What is the ratio of the Number of enrolments of both sexes of Cambodia in 2004 to that in 2009?
Keep it short and to the point. 0.67. What is the ratio of the Number of enrolments of both sexes in France in 2004 to that in 2009?
Offer a very short reply. 0.91. What is the ratio of the Number of enrolments of both sexes of Lesotho in 2004 to that in 2009?
Provide a short and direct response. 0.79. What is the ratio of the Number of enrolments of both sexes of Middle East & North Africa (all income levels) in 2004 to that in 2010?
Your answer should be very brief. 0.96. What is the ratio of the Number of enrolments of both sexes of Cambodia in 2004 to that in 2010?
Your answer should be very brief. 0.67. What is the ratio of the Number of enrolments of both sexes of France in 2004 to that in 2010?
Provide a short and direct response. 0.91. What is the ratio of the Number of enrolments of both sexes of Lesotho in 2004 to that in 2010?
Offer a terse response. 0.71. What is the ratio of the Number of enrolments of both sexes in Middle East & North Africa (all income levels) in 2005 to that in 2006?
Provide a succinct answer. 0.99. What is the ratio of the Number of enrolments of both sexes in Cambodia in 2005 to that in 2006?
Your answer should be very brief. 0.89. What is the ratio of the Number of enrolments of both sexes of France in 2005 to that in 2006?
Provide a succinct answer. 0.92. What is the ratio of the Number of enrolments of both sexes in Lesotho in 2005 to that in 2006?
Keep it short and to the point. 0.98. What is the ratio of the Number of enrolments of both sexes in Cambodia in 2005 to that in 2007?
Provide a succinct answer. 0.83. What is the ratio of the Number of enrolments of both sexes of France in 2005 to that in 2007?
Your response must be concise. 0.93. What is the ratio of the Number of enrolments of both sexes of Lesotho in 2005 to that in 2007?
Your answer should be compact. 0.95. What is the ratio of the Number of enrolments of both sexes of Middle East & North Africa (all income levels) in 2005 to that in 2008?
Your answer should be compact. 0.98. What is the ratio of the Number of enrolments of both sexes in Cambodia in 2005 to that in 2008?
Ensure brevity in your answer.  0.78. What is the ratio of the Number of enrolments of both sexes of France in 2005 to that in 2008?
Give a very brief answer. 0.94. What is the ratio of the Number of enrolments of both sexes in Lesotho in 2005 to that in 2008?
Offer a very short reply. 0.9. What is the ratio of the Number of enrolments of both sexes of Middle East & North Africa (all income levels) in 2005 to that in 2009?
Keep it short and to the point. 0.97. What is the ratio of the Number of enrolments of both sexes in Cambodia in 2005 to that in 2009?
Provide a short and direct response. 0.77. What is the ratio of the Number of enrolments of both sexes in France in 2005 to that in 2009?
Your answer should be very brief. 0.94. What is the ratio of the Number of enrolments of both sexes of Lesotho in 2005 to that in 2009?
Your response must be concise. 0.84. What is the ratio of the Number of enrolments of both sexes in Middle East & North Africa (all income levels) in 2005 to that in 2010?
Give a very brief answer. 0.97. What is the ratio of the Number of enrolments of both sexes in Cambodia in 2005 to that in 2010?
Your response must be concise. 0.77. What is the ratio of the Number of enrolments of both sexes in France in 2005 to that in 2010?
Provide a succinct answer. 0.94. What is the ratio of the Number of enrolments of both sexes of Lesotho in 2005 to that in 2010?
Offer a very short reply. 0.76. What is the ratio of the Number of enrolments of both sexes in Cambodia in 2006 to that in 2007?
Give a very brief answer. 0.93. What is the ratio of the Number of enrolments of both sexes of France in 2006 to that in 2007?
Ensure brevity in your answer.  1.01. What is the ratio of the Number of enrolments of both sexes in Lesotho in 2006 to that in 2007?
Your response must be concise. 0.97. What is the ratio of the Number of enrolments of both sexes in Middle East & North Africa (all income levels) in 2006 to that in 2008?
Offer a terse response. 0.98. What is the ratio of the Number of enrolments of both sexes in Cambodia in 2006 to that in 2008?
Your answer should be very brief. 0.88. What is the ratio of the Number of enrolments of both sexes in Lesotho in 2006 to that in 2008?
Your response must be concise. 0.92. What is the ratio of the Number of enrolments of both sexes of Middle East & North Africa (all income levels) in 2006 to that in 2009?
Your answer should be very brief. 0.98. What is the ratio of the Number of enrolments of both sexes in Cambodia in 2006 to that in 2009?
Provide a short and direct response. 0.87. What is the ratio of the Number of enrolments of both sexes in France in 2006 to that in 2009?
Make the answer very short. 1.03. What is the ratio of the Number of enrolments of both sexes of Lesotho in 2006 to that in 2009?
Give a very brief answer. 0.85. What is the ratio of the Number of enrolments of both sexes in Middle East & North Africa (all income levels) in 2006 to that in 2010?
Give a very brief answer. 0.97. What is the ratio of the Number of enrolments of both sexes of Cambodia in 2006 to that in 2010?
Ensure brevity in your answer.  0.86. What is the ratio of the Number of enrolments of both sexes of France in 2006 to that in 2010?
Ensure brevity in your answer.  1.03. What is the ratio of the Number of enrolments of both sexes of Lesotho in 2006 to that in 2010?
Provide a short and direct response. 0.77. What is the ratio of the Number of enrolments of both sexes of Middle East & North Africa (all income levels) in 2007 to that in 2008?
Keep it short and to the point. 0.99. What is the ratio of the Number of enrolments of both sexes of Cambodia in 2007 to that in 2008?
Provide a succinct answer. 0.94. What is the ratio of the Number of enrolments of both sexes of France in 2007 to that in 2008?
Make the answer very short. 1.01. What is the ratio of the Number of enrolments of both sexes in Lesotho in 2007 to that in 2008?
Provide a succinct answer. 0.95. What is the ratio of the Number of enrolments of both sexes in Middle East & North Africa (all income levels) in 2007 to that in 2009?
Provide a succinct answer. 0.98. What is the ratio of the Number of enrolments of both sexes of Cambodia in 2007 to that in 2009?
Provide a short and direct response. 0.93. What is the ratio of the Number of enrolments of both sexes of France in 2007 to that in 2009?
Your response must be concise. 1.01. What is the ratio of the Number of enrolments of both sexes in Lesotho in 2007 to that in 2009?
Your answer should be compact. 0.88. What is the ratio of the Number of enrolments of both sexes of Middle East & North Africa (all income levels) in 2007 to that in 2010?
Provide a succinct answer. 0.98. What is the ratio of the Number of enrolments of both sexes in Cambodia in 2007 to that in 2010?
Your response must be concise. 0.92. What is the ratio of the Number of enrolments of both sexes in France in 2007 to that in 2010?
Offer a very short reply. 1.01. What is the ratio of the Number of enrolments of both sexes of Lesotho in 2007 to that in 2010?
Offer a terse response. 0.79. What is the ratio of the Number of enrolments of both sexes of Lesotho in 2008 to that in 2009?
Your answer should be very brief. 0.93. What is the ratio of the Number of enrolments of both sexes of Middle East & North Africa (all income levels) in 2008 to that in 2010?
Provide a succinct answer. 0.99. What is the ratio of the Number of enrolments of both sexes of Cambodia in 2008 to that in 2010?
Your answer should be compact. 0.98. What is the ratio of the Number of enrolments of both sexes in Lesotho in 2008 to that in 2010?
Your answer should be very brief. 0.84. What is the ratio of the Number of enrolments of both sexes in Middle East & North Africa (all income levels) in 2009 to that in 2010?
Ensure brevity in your answer.  1. What is the ratio of the Number of enrolments of both sexes of Cambodia in 2009 to that in 2010?
Provide a short and direct response. 0.99. What is the ratio of the Number of enrolments of both sexes of France in 2009 to that in 2010?
Provide a short and direct response. 1. What is the ratio of the Number of enrolments of both sexes of Lesotho in 2009 to that in 2010?
Ensure brevity in your answer.  0.9. What is the difference between the highest and the second highest Number of enrolments of both sexes in Middle East & North Africa (all income levels)?
Provide a succinct answer. 7.55e+04. What is the difference between the highest and the second highest Number of enrolments of both sexes in Cambodia?
Give a very brief answer. 7080. What is the difference between the highest and the second highest Number of enrolments of both sexes of France?
Your response must be concise. 6.85e+04. What is the difference between the highest and the second highest Number of enrolments of both sexes of Lesotho?
Make the answer very short. 1.18e+04. What is the difference between the highest and the lowest Number of enrolments of both sexes of Middle East & North Africa (all income levels)?
Ensure brevity in your answer.  1.24e+06. What is the difference between the highest and the lowest Number of enrolments of both sexes of Cambodia?
Ensure brevity in your answer.  3.10e+05. What is the difference between the highest and the lowest Number of enrolments of both sexes of France?
Keep it short and to the point. 5.31e+05. What is the difference between the highest and the lowest Number of enrolments of both sexes in Lesotho?
Provide a succinct answer. 3.52e+04. 